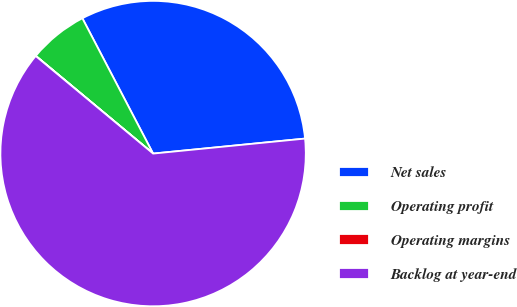<chart> <loc_0><loc_0><loc_500><loc_500><pie_chart><fcel>Net sales<fcel>Operating profit<fcel>Operating margins<fcel>Backlog at year-end<nl><fcel>31.1%<fcel>6.28%<fcel>0.02%<fcel>62.6%<nl></chart> 